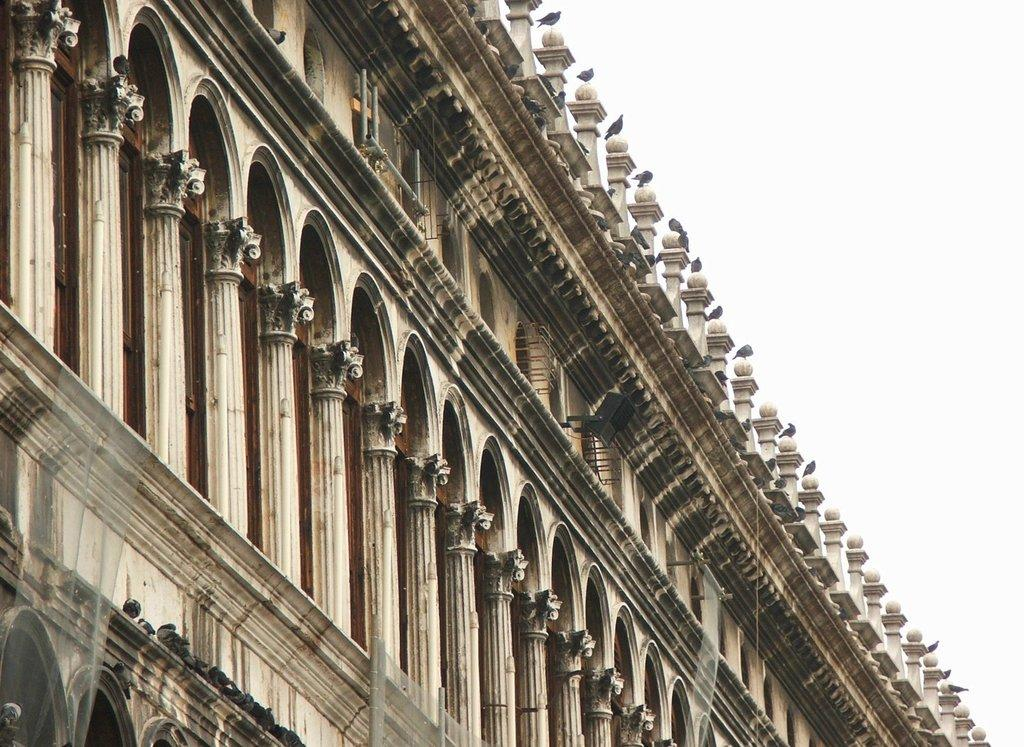What type of structure is shown in the image? The image depicts an old monument. What material is the monument made of? The monument has stone walls. What architectural features can be seen on the monument? The monument has pillars. Are there any openings in the monument? Yes, the monument has small windows. What can be seen on top of the monument? Birds are sitting on the pillars at the top of the monument. What type of scene is depicted in the image? The image does not depict a scene; it shows an old monument with stone walls, pillars, small windows, and birds sitting on the pillars. What role does the monument play in leading people to a specific location? The monument does not have a role in leading people to a specific location; it is a historical structure with architectural and aesthetic value. 